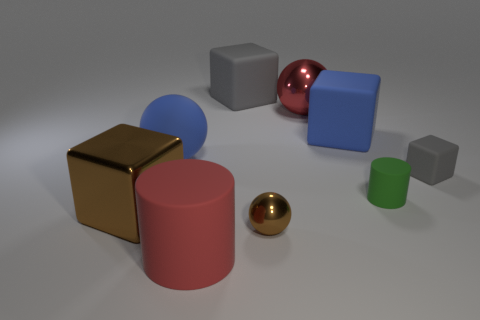What number of balls are both in front of the red shiny object and behind the shiny cube?
Make the answer very short. 1. There is a gray block on the left side of the large metal sphere; what is its material?
Offer a very short reply. Rubber. There is a green cylinder that is the same material as the tiny cube; what size is it?
Your answer should be compact. Small. Does the brown object behind the small brown metal sphere have the same size as the cylinder behind the red matte thing?
Give a very brief answer. No. There is a gray cube that is the same size as the green rubber cylinder; what is it made of?
Provide a succinct answer. Rubber. There is a large object that is in front of the green object and to the right of the shiny block; what is its material?
Provide a short and direct response. Rubber. Are any small gray matte blocks visible?
Your response must be concise. Yes. There is a tiny rubber block; is its color the same as the large ball that is in front of the large blue matte cube?
Provide a short and direct response. No. What material is the big object that is the same color as the small metal sphere?
Your response must be concise. Metal. Is there any other thing that is the same shape as the large brown metal thing?
Keep it short and to the point. Yes. 